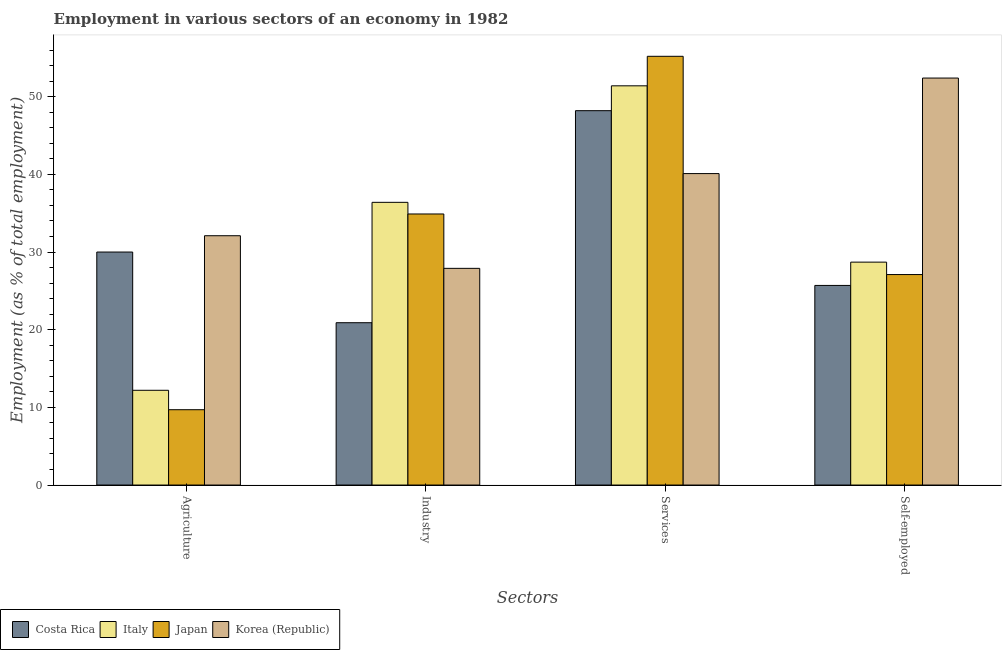How many different coloured bars are there?
Ensure brevity in your answer.  4. Are the number of bars on each tick of the X-axis equal?
Your response must be concise. Yes. What is the label of the 1st group of bars from the left?
Keep it short and to the point. Agriculture. What is the percentage of workers in agriculture in Korea (Republic)?
Make the answer very short. 32.1. Across all countries, what is the maximum percentage of self employed workers?
Make the answer very short. 52.4. Across all countries, what is the minimum percentage of workers in services?
Your answer should be very brief. 40.1. In which country was the percentage of workers in agriculture maximum?
Keep it short and to the point. Korea (Republic). What is the total percentage of workers in agriculture in the graph?
Keep it short and to the point. 84. What is the difference between the percentage of self employed workers in Japan and that in Costa Rica?
Provide a short and direct response. 1.4. What is the difference between the percentage of workers in agriculture in Korea (Republic) and the percentage of workers in industry in Japan?
Provide a short and direct response. -2.8. What is the average percentage of workers in services per country?
Make the answer very short. 48.73. What is the difference between the percentage of workers in agriculture and percentage of workers in industry in Italy?
Offer a terse response. -24.2. What is the ratio of the percentage of self employed workers in Japan to that in Italy?
Offer a terse response. 0.94. What is the difference between the highest and the second highest percentage of workers in services?
Offer a terse response. 3.8. What is the difference between the highest and the lowest percentage of workers in industry?
Your answer should be compact. 15.5. In how many countries, is the percentage of self employed workers greater than the average percentage of self employed workers taken over all countries?
Your answer should be very brief. 1. Is the sum of the percentage of workers in services in Korea (Republic) and Japan greater than the maximum percentage of workers in industry across all countries?
Offer a terse response. Yes. Is it the case that in every country, the sum of the percentage of self employed workers and percentage of workers in services is greater than the sum of percentage of workers in agriculture and percentage of workers in industry?
Ensure brevity in your answer.  No. Is it the case that in every country, the sum of the percentage of workers in agriculture and percentage of workers in industry is greater than the percentage of workers in services?
Make the answer very short. No. How many bars are there?
Your response must be concise. 16. Are all the bars in the graph horizontal?
Make the answer very short. No. What is the difference between two consecutive major ticks on the Y-axis?
Your response must be concise. 10. Are the values on the major ticks of Y-axis written in scientific E-notation?
Your answer should be compact. No. Where does the legend appear in the graph?
Provide a succinct answer. Bottom left. How are the legend labels stacked?
Offer a very short reply. Horizontal. What is the title of the graph?
Make the answer very short. Employment in various sectors of an economy in 1982. What is the label or title of the X-axis?
Your response must be concise. Sectors. What is the label or title of the Y-axis?
Your answer should be very brief. Employment (as % of total employment). What is the Employment (as % of total employment) in Costa Rica in Agriculture?
Your answer should be very brief. 30. What is the Employment (as % of total employment) in Italy in Agriculture?
Provide a succinct answer. 12.2. What is the Employment (as % of total employment) in Japan in Agriculture?
Give a very brief answer. 9.7. What is the Employment (as % of total employment) in Korea (Republic) in Agriculture?
Provide a short and direct response. 32.1. What is the Employment (as % of total employment) of Costa Rica in Industry?
Provide a succinct answer. 20.9. What is the Employment (as % of total employment) in Italy in Industry?
Provide a short and direct response. 36.4. What is the Employment (as % of total employment) in Japan in Industry?
Offer a very short reply. 34.9. What is the Employment (as % of total employment) in Korea (Republic) in Industry?
Provide a short and direct response. 27.9. What is the Employment (as % of total employment) in Costa Rica in Services?
Give a very brief answer. 48.2. What is the Employment (as % of total employment) of Italy in Services?
Your response must be concise. 51.4. What is the Employment (as % of total employment) of Japan in Services?
Provide a short and direct response. 55.2. What is the Employment (as % of total employment) of Korea (Republic) in Services?
Offer a terse response. 40.1. What is the Employment (as % of total employment) in Costa Rica in Self-employed?
Ensure brevity in your answer.  25.7. What is the Employment (as % of total employment) of Italy in Self-employed?
Provide a succinct answer. 28.7. What is the Employment (as % of total employment) in Japan in Self-employed?
Ensure brevity in your answer.  27.1. What is the Employment (as % of total employment) of Korea (Republic) in Self-employed?
Ensure brevity in your answer.  52.4. Across all Sectors, what is the maximum Employment (as % of total employment) of Costa Rica?
Provide a succinct answer. 48.2. Across all Sectors, what is the maximum Employment (as % of total employment) of Italy?
Your answer should be compact. 51.4. Across all Sectors, what is the maximum Employment (as % of total employment) in Japan?
Give a very brief answer. 55.2. Across all Sectors, what is the maximum Employment (as % of total employment) in Korea (Republic)?
Offer a very short reply. 52.4. Across all Sectors, what is the minimum Employment (as % of total employment) in Costa Rica?
Keep it short and to the point. 20.9. Across all Sectors, what is the minimum Employment (as % of total employment) in Italy?
Provide a short and direct response. 12.2. Across all Sectors, what is the minimum Employment (as % of total employment) of Japan?
Your response must be concise. 9.7. Across all Sectors, what is the minimum Employment (as % of total employment) in Korea (Republic)?
Offer a very short reply. 27.9. What is the total Employment (as % of total employment) of Costa Rica in the graph?
Keep it short and to the point. 124.8. What is the total Employment (as % of total employment) in Italy in the graph?
Ensure brevity in your answer.  128.7. What is the total Employment (as % of total employment) in Japan in the graph?
Your answer should be compact. 126.9. What is the total Employment (as % of total employment) in Korea (Republic) in the graph?
Your answer should be compact. 152.5. What is the difference between the Employment (as % of total employment) in Costa Rica in Agriculture and that in Industry?
Give a very brief answer. 9.1. What is the difference between the Employment (as % of total employment) in Italy in Agriculture and that in Industry?
Provide a succinct answer. -24.2. What is the difference between the Employment (as % of total employment) of Japan in Agriculture and that in Industry?
Offer a very short reply. -25.2. What is the difference between the Employment (as % of total employment) in Korea (Republic) in Agriculture and that in Industry?
Offer a terse response. 4.2. What is the difference between the Employment (as % of total employment) of Costa Rica in Agriculture and that in Services?
Provide a short and direct response. -18.2. What is the difference between the Employment (as % of total employment) in Italy in Agriculture and that in Services?
Your response must be concise. -39.2. What is the difference between the Employment (as % of total employment) in Japan in Agriculture and that in Services?
Give a very brief answer. -45.5. What is the difference between the Employment (as % of total employment) in Italy in Agriculture and that in Self-employed?
Keep it short and to the point. -16.5. What is the difference between the Employment (as % of total employment) of Japan in Agriculture and that in Self-employed?
Offer a very short reply. -17.4. What is the difference between the Employment (as % of total employment) in Korea (Republic) in Agriculture and that in Self-employed?
Provide a short and direct response. -20.3. What is the difference between the Employment (as % of total employment) of Costa Rica in Industry and that in Services?
Your answer should be very brief. -27.3. What is the difference between the Employment (as % of total employment) of Japan in Industry and that in Services?
Ensure brevity in your answer.  -20.3. What is the difference between the Employment (as % of total employment) of Korea (Republic) in Industry and that in Services?
Your answer should be compact. -12.2. What is the difference between the Employment (as % of total employment) of Japan in Industry and that in Self-employed?
Ensure brevity in your answer.  7.8. What is the difference between the Employment (as % of total employment) in Korea (Republic) in Industry and that in Self-employed?
Ensure brevity in your answer.  -24.5. What is the difference between the Employment (as % of total employment) in Italy in Services and that in Self-employed?
Offer a very short reply. 22.7. What is the difference between the Employment (as % of total employment) of Japan in Services and that in Self-employed?
Keep it short and to the point. 28.1. What is the difference between the Employment (as % of total employment) in Costa Rica in Agriculture and the Employment (as % of total employment) in Italy in Industry?
Your answer should be compact. -6.4. What is the difference between the Employment (as % of total employment) in Costa Rica in Agriculture and the Employment (as % of total employment) in Japan in Industry?
Keep it short and to the point. -4.9. What is the difference between the Employment (as % of total employment) of Costa Rica in Agriculture and the Employment (as % of total employment) of Korea (Republic) in Industry?
Keep it short and to the point. 2.1. What is the difference between the Employment (as % of total employment) of Italy in Agriculture and the Employment (as % of total employment) of Japan in Industry?
Give a very brief answer. -22.7. What is the difference between the Employment (as % of total employment) in Italy in Agriculture and the Employment (as % of total employment) in Korea (Republic) in Industry?
Make the answer very short. -15.7. What is the difference between the Employment (as % of total employment) of Japan in Agriculture and the Employment (as % of total employment) of Korea (Republic) in Industry?
Your answer should be compact. -18.2. What is the difference between the Employment (as % of total employment) in Costa Rica in Agriculture and the Employment (as % of total employment) in Italy in Services?
Make the answer very short. -21.4. What is the difference between the Employment (as % of total employment) in Costa Rica in Agriculture and the Employment (as % of total employment) in Japan in Services?
Offer a terse response. -25.2. What is the difference between the Employment (as % of total employment) of Italy in Agriculture and the Employment (as % of total employment) of Japan in Services?
Give a very brief answer. -43. What is the difference between the Employment (as % of total employment) in Italy in Agriculture and the Employment (as % of total employment) in Korea (Republic) in Services?
Your answer should be very brief. -27.9. What is the difference between the Employment (as % of total employment) of Japan in Agriculture and the Employment (as % of total employment) of Korea (Republic) in Services?
Ensure brevity in your answer.  -30.4. What is the difference between the Employment (as % of total employment) of Costa Rica in Agriculture and the Employment (as % of total employment) of Korea (Republic) in Self-employed?
Provide a short and direct response. -22.4. What is the difference between the Employment (as % of total employment) in Italy in Agriculture and the Employment (as % of total employment) in Japan in Self-employed?
Your response must be concise. -14.9. What is the difference between the Employment (as % of total employment) of Italy in Agriculture and the Employment (as % of total employment) of Korea (Republic) in Self-employed?
Provide a succinct answer. -40.2. What is the difference between the Employment (as % of total employment) in Japan in Agriculture and the Employment (as % of total employment) in Korea (Republic) in Self-employed?
Give a very brief answer. -42.7. What is the difference between the Employment (as % of total employment) in Costa Rica in Industry and the Employment (as % of total employment) in Italy in Services?
Offer a terse response. -30.5. What is the difference between the Employment (as % of total employment) in Costa Rica in Industry and the Employment (as % of total employment) in Japan in Services?
Ensure brevity in your answer.  -34.3. What is the difference between the Employment (as % of total employment) in Costa Rica in Industry and the Employment (as % of total employment) in Korea (Republic) in Services?
Give a very brief answer. -19.2. What is the difference between the Employment (as % of total employment) of Italy in Industry and the Employment (as % of total employment) of Japan in Services?
Your response must be concise. -18.8. What is the difference between the Employment (as % of total employment) of Costa Rica in Industry and the Employment (as % of total employment) of Italy in Self-employed?
Make the answer very short. -7.8. What is the difference between the Employment (as % of total employment) in Costa Rica in Industry and the Employment (as % of total employment) in Japan in Self-employed?
Offer a very short reply. -6.2. What is the difference between the Employment (as % of total employment) of Costa Rica in Industry and the Employment (as % of total employment) of Korea (Republic) in Self-employed?
Offer a terse response. -31.5. What is the difference between the Employment (as % of total employment) of Italy in Industry and the Employment (as % of total employment) of Japan in Self-employed?
Ensure brevity in your answer.  9.3. What is the difference between the Employment (as % of total employment) in Japan in Industry and the Employment (as % of total employment) in Korea (Republic) in Self-employed?
Your answer should be very brief. -17.5. What is the difference between the Employment (as % of total employment) of Costa Rica in Services and the Employment (as % of total employment) of Italy in Self-employed?
Ensure brevity in your answer.  19.5. What is the difference between the Employment (as % of total employment) of Costa Rica in Services and the Employment (as % of total employment) of Japan in Self-employed?
Ensure brevity in your answer.  21.1. What is the difference between the Employment (as % of total employment) in Italy in Services and the Employment (as % of total employment) in Japan in Self-employed?
Provide a succinct answer. 24.3. What is the difference between the Employment (as % of total employment) in Italy in Services and the Employment (as % of total employment) in Korea (Republic) in Self-employed?
Offer a very short reply. -1. What is the difference between the Employment (as % of total employment) in Japan in Services and the Employment (as % of total employment) in Korea (Republic) in Self-employed?
Offer a very short reply. 2.8. What is the average Employment (as % of total employment) of Costa Rica per Sectors?
Make the answer very short. 31.2. What is the average Employment (as % of total employment) in Italy per Sectors?
Make the answer very short. 32.17. What is the average Employment (as % of total employment) in Japan per Sectors?
Give a very brief answer. 31.73. What is the average Employment (as % of total employment) in Korea (Republic) per Sectors?
Give a very brief answer. 38.12. What is the difference between the Employment (as % of total employment) of Costa Rica and Employment (as % of total employment) of Italy in Agriculture?
Your answer should be very brief. 17.8. What is the difference between the Employment (as % of total employment) of Costa Rica and Employment (as % of total employment) of Japan in Agriculture?
Your answer should be compact. 20.3. What is the difference between the Employment (as % of total employment) in Italy and Employment (as % of total employment) in Japan in Agriculture?
Provide a short and direct response. 2.5. What is the difference between the Employment (as % of total employment) of Italy and Employment (as % of total employment) of Korea (Republic) in Agriculture?
Your answer should be compact. -19.9. What is the difference between the Employment (as % of total employment) in Japan and Employment (as % of total employment) in Korea (Republic) in Agriculture?
Make the answer very short. -22.4. What is the difference between the Employment (as % of total employment) in Costa Rica and Employment (as % of total employment) in Italy in Industry?
Provide a succinct answer. -15.5. What is the difference between the Employment (as % of total employment) in Italy and Employment (as % of total employment) in Japan in Industry?
Offer a terse response. 1.5. What is the difference between the Employment (as % of total employment) in Japan and Employment (as % of total employment) in Korea (Republic) in Industry?
Offer a terse response. 7. What is the difference between the Employment (as % of total employment) in Costa Rica and Employment (as % of total employment) in Italy in Services?
Ensure brevity in your answer.  -3.2. What is the difference between the Employment (as % of total employment) in Italy and Employment (as % of total employment) in Japan in Services?
Provide a succinct answer. -3.8. What is the difference between the Employment (as % of total employment) of Japan and Employment (as % of total employment) of Korea (Republic) in Services?
Your answer should be compact. 15.1. What is the difference between the Employment (as % of total employment) in Costa Rica and Employment (as % of total employment) in Korea (Republic) in Self-employed?
Provide a short and direct response. -26.7. What is the difference between the Employment (as % of total employment) in Italy and Employment (as % of total employment) in Korea (Republic) in Self-employed?
Ensure brevity in your answer.  -23.7. What is the difference between the Employment (as % of total employment) of Japan and Employment (as % of total employment) of Korea (Republic) in Self-employed?
Your answer should be compact. -25.3. What is the ratio of the Employment (as % of total employment) of Costa Rica in Agriculture to that in Industry?
Your answer should be compact. 1.44. What is the ratio of the Employment (as % of total employment) of Italy in Agriculture to that in Industry?
Ensure brevity in your answer.  0.34. What is the ratio of the Employment (as % of total employment) of Japan in Agriculture to that in Industry?
Provide a short and direct response. 0.28. What is the ratio of the Employment (as % of total employment) of Korea (Republic) in Agriculture to that in Industry?
Make the answer very short. 1.15. What is the ratio of the Employment (as % of total employment) in Costa Rica in Agriculture to that in Services?
Offer a very short reply. 0.62. What is the ratio of the Employment (as % of total employment) of Italy in Agriculture to that in Services?
Offer a terse response. 0.24. What is the ratio of the Employment (as % of total employment) of Japan in Agriculture to that in Services?
Offer a very short reply. 0.18. What is the ratio of the Employment (as % of total employment) of Korea (Republic) in Agriculture to that in Services?
Make the answer very short. 0.8. What is the ratio of the Employment (as % of total employment) in Costa Rica in Agriculture to that in Self-employed?
Your response must be concise. 1.17. What is the ratio of the Employment (as % of total employment) in Italy in Agriculture to that in Self-employed?
Provide a succinct answer. 0.43. What is the ratio of the Employment (as % of total employment) of Japan in Agriculture to that in Self-employed?
Your answer should be very brief. 0.36. What is the ratio of the Employment (as % of total employment) of Korea (Republic) in Agriculture to that in Self-employed?
Give a very brief answer. 0.61. What is the ratio of the Employment (as % of total employment) of Costa Rica in Industry to that in Services?
Make the answer very short. 0.43. What is the ratio of the Employment (as % of total employment) in Italy in Industry to that in Services?
Provide a succinct answer. 0.71. What is the ratio of the Employment (as % of total employment) in Japan in Industry to that in Services?
Your answer should be very brief. 0.63. What is the ratio of the Employment (as % of total employment) of Korea (Republic) in Industry to that in Services?
Provide a short and direct response. 0.7. What is the ratio of the Employment (as % of total employment) of Costa Rica in Industry to that in Self-employed?
Your answer should be compact. 0.81. What is the ratio of the Employment (as % of total employment) in Italy in Industry to that in Self-employed?
Your response must be concise. 1.27. What is the ratio of the Employment (as % of total employment) in Japan in Industry to that in Self-employed?
Your response must be concise. 1.29. What is the ratio of the Employment (as % of total employment) of Korea (Republic) in Industry to that in Self-employed?
Provide a short and direct response. 0.53. What is the ratio of the Employment (as % of total employment) in Costa Rica in Services to that in Self-employed?
Keep it short and to the point. 1.88. What is the ratio of the Employment (as % of total employment) in Italy in Services to that in Self-employed?
Keep it short and to the point. 1.79. What is the ratio of the Employment (as % of total employment) in Japan in Services to that in Self-employed?
Your answer should be compact. 2.04. What is the ratio of the Employment (as % of total employment) of Korea (Republic) in Services to that in Self-employed?
Make the answer very short. 0.77. What is the difference between the highest and the second highest Employment (as % of total employment) of Costa Rica?
Your response must be concise. 18.2. What is the difference between the highest and the second highest Employment (as % of total employment) of Japan?
Give a very brief answer. 20.3. What is the difference between the highest and the second highest Employment (as % of total employment) in Korea (Republic)?
Offer a very short reply. 12.3. What is the difference between the highest and the lowest Employment (as % of total employment) of Costa Rica?
Ensure brevity in your answer.  27.3. What is the difference between the highest and the lowest Employment (as % of total employment) of Italy?
Keep it short and to the point. 39.2. What is the difference between the highest and the lowest Employment (as % of total employment) in Japan?
Your response must be concise. 45.5. What is the difference between the highest and the lowest Employment (as % of total employment) in Korea (Republic)?
Your response must be concise. 24.5. 